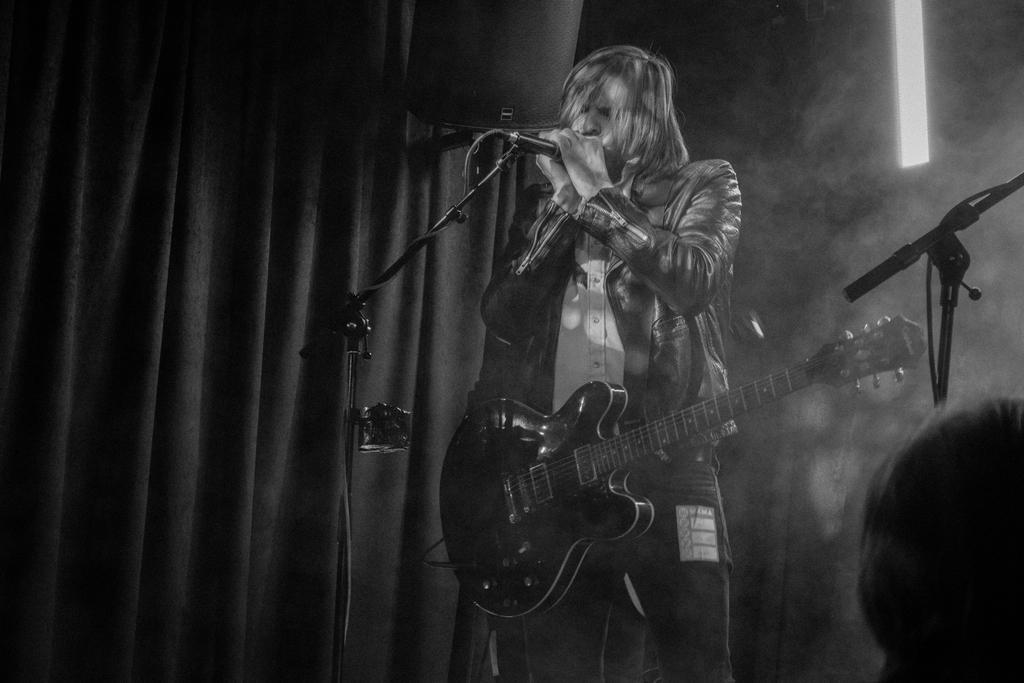Can you describe this image briefly? It is a black and white image a person is standing and singing there is a mic in front of him he is wearing a guitar in the background there is sunlight, curtains and a wall. 